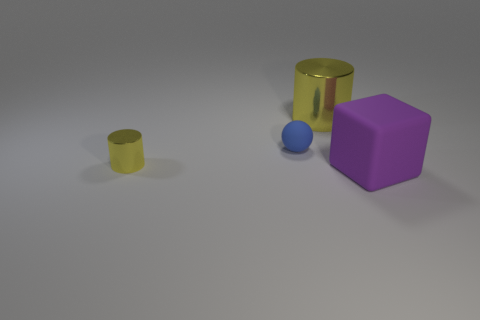Add 1 small blue matte cylinders. How many objects exist? 5 Subtract all spheres. How many objects are left? 3 Subtract all large metal cylinders. Subtract all small blue balls. How many objects are left? 2 Add 4 small blue balls. How many small blue balls are left? 5 Add 3 large purple rubber things. How many large purple rubber things exist? 4 Subtract 1 purple cubes. How many objects are left? 3 